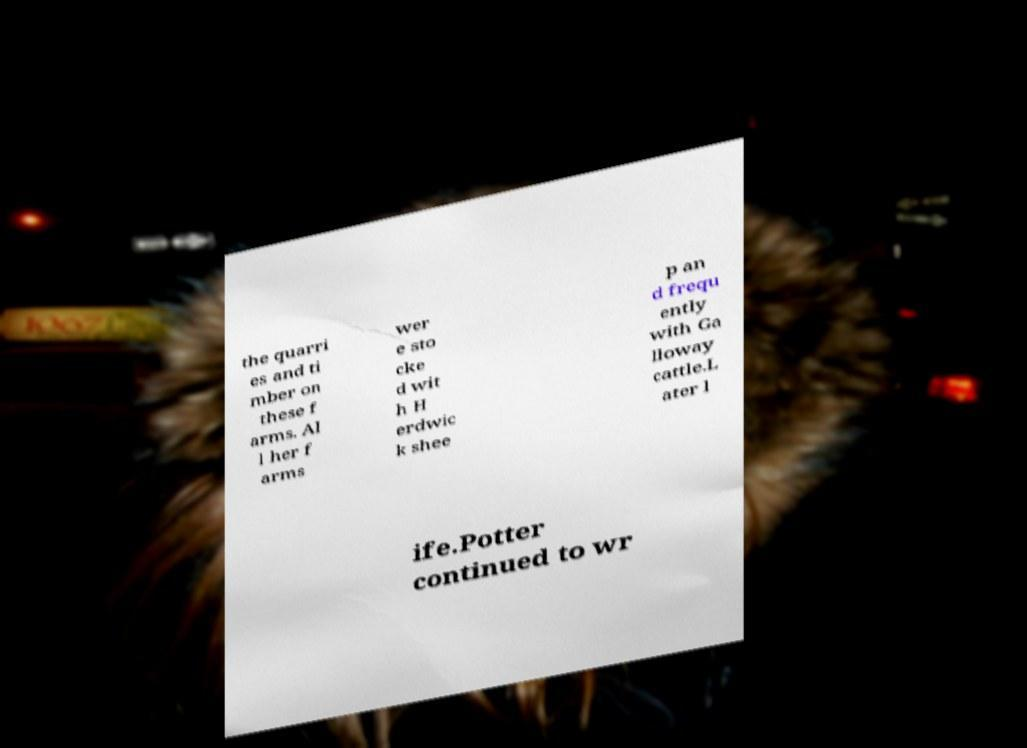I need the written content from this picture converted into text. Can you do that? the quarri es and ti mber on these f arms. Al l her f arms wer e sto cke d wit h H erdwic k shee p an d frequ ently with Ga lloway cattle.L ater l ife.Potter continued to wr 